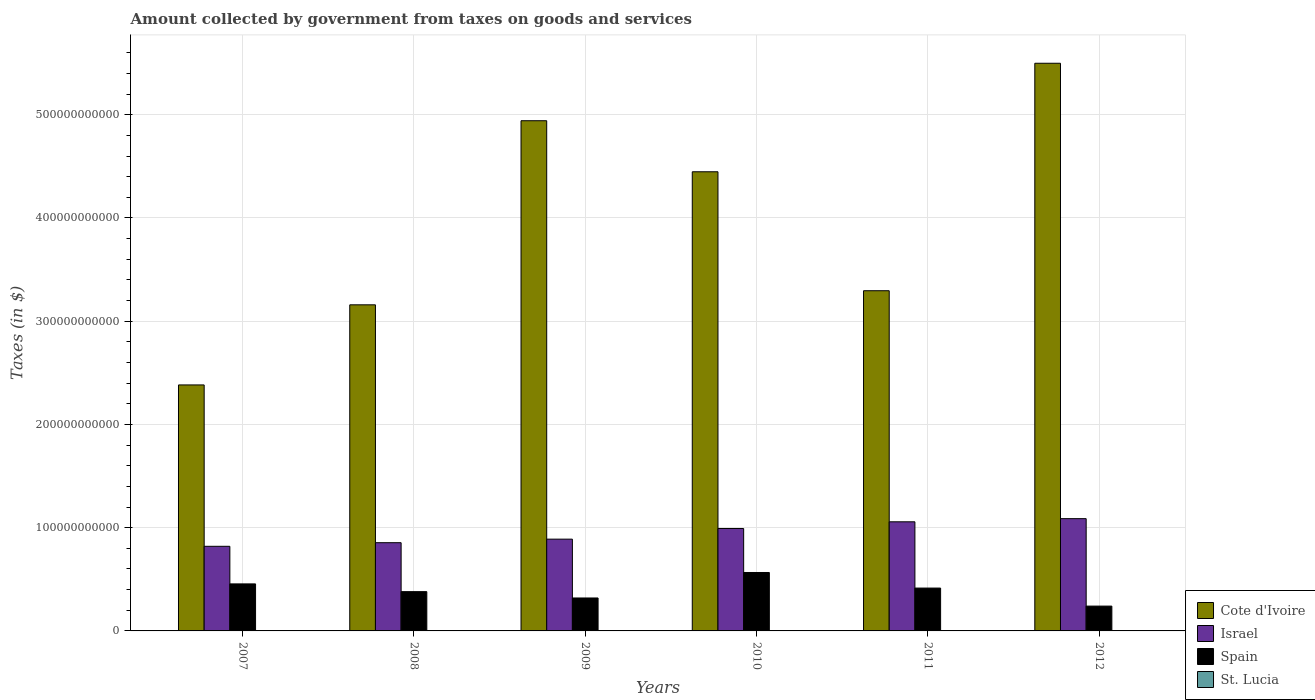How many different coloured bars are there?
Your response must be concise. 4. How many groups of bars are there?
Your answer should be compact. 6. Are the number of bars per tick equal to the number of legend labels?
Ensure brevity in your answer.  Yes. How many bars are there on the 4th tick from the left?
Provide a succinct answer. 4. In how many cases, is the number of bars for a given year not equal to the number of legend labels?
Give a very brief answer. 0. What is the amount collected by government from taxes on goods and services in Cote d'Ivoire in 2011?
Your response must be concise. 3.30e+11. Across all years, what is the maximum amount collected by government from taxes on goods and services in Israel?
Offer a terse response. 1.09e+11. Across all years, what is the minimum amount collected by government from taxes on goods and services in Cote d'Ivoire?
Provide a short and direct response. 2.38e+11. What is the total amount collected by government from taxes on goods and services in Israel in the graph?
Offer a terse response. 5.70e+11. What is the difference between the amount collected by government from taxes on goods and services in St. Lucia in 2007 and that in 2011?
Provide a succinct answer. -6.00e+06. What is the difference between the amount collected by government from taxes on goods and services in Spain in 2007 and the amount collected by government from taxes on goods and services in Cote d'Ivoire in 2011?
Offer a very short reply. -2.84e+11. What is the average amount collected by government from taxes on goods and services in Cote d'Ivoire per year?
Offer a very short reply. 3.95e+11. In the year 2011, what is the difference between the amount collected by government from taxes on goods and services in Israel and amount collected by government from taxes on goods and services in Spain?
Keep it short and to the point. 6.42e+1. What is the ratio of the amount collected by government from taxes on goods and services in Cote d'Ivoire in 2008 to that in 2010?
Make the answer very short. 0.71. Is the amount collected by government from taxes on goods and services in St. Lucia in 2007 less than that in 2010?
Your answer should be compact. Yes. Is the difference between the amount collected by government from taxes on goods and services in Israel in 2007 and 2008 greater than the difference between the amount collected by government from taxes on goods and services in Spain in 2007 and 2008?
Make the answer very short. No. What is the difference between the highest and the second highest amount collected by government from taxes on goods and services in Spain?
Your answer should be compact. 1.11e+1. What is the difference between the highest and the lowest amount collected by government from taxes on goods and services in Cote d'Ivoire?
Provide a succinct answer. 3.12e+11. Is it the case that in every year, the sum of the amount collected by government from taxes on goods and services in St. Lucia and amount collected by government from taxes on goods and services in Israel is greater than the sum of amount collected by government from taxes on goods and services in Spain and amount collected by government from taxes on goods and services in Cote d'Ivoire?
Provide a short and direct response. No. What does the 1st bar from the right in 2007 represents?
Provide a succinct answer. St. Lucia. Is it the case that in every year, the sum of the amount collected by government from taxes on goods and services in Spain and amount collected by government from taxes on goods and services in Cote d'Ivoire is greater than the amount collected by government from taxes on goods and services in St. Lucia?
Provide a succinct answer. Yes. How many bars are there?
Give a very brief answer. 24. What is the difference between two consecutive major ticks on the Y-axis?
Your answer should be compact. 1.00e+11. Are the values on the major ticks of Y-axis written in scientific E-notation?
Ensure brevity in your answer.  No. Does the graph contain grids?
Keep it short and to the point. Yes. What is the title of the graph?
Provide a short and direct response. Amount collected by government from taxes on goods and services. What is the label or title of the X-axis?
Offer a very short reply. Years. What is the label or title of the Y-axis?
Offer a terse response. Taxes (in $). What is the Taxes (in $) of Cote d'Ivoire in 2007?
Offer a very short reply. 2.38e+11. What is the Taxes (in $) in Israel in 2007?
Your response must be concise. 8.20e+1. What is the Taxes (in $) in Spain in 2007?
Make the answer very short. 4.55e+1. What is the Taxes (in $) in St. Lucia in 2007?
Ensure brevity in your answer.  1.20e+08. What is the Taxes (in $) of Cote d'Ivoire in 2008?
Make the answer very short. 3.16e+11. What is the Taxes (in $) of Israel in 2008?
Provide a short and direct response. 8.55e+1. What is the Taxes (in $) in Spain in 2008?
Make the answer very short. 3.80e+1. What is the Taxes (in $) of St. Lucia in 2008?
Your answer should be compact. 1.32e+08. What is the Taxes (in $) in Cote d'Ivoire in 2009?
Make the answer very short. 4.94e+11. What is the Taxes (in $) of Israel in 2009?
Give a very brief answer. 8.89e+1. What is the Taxes (in $) in Spain in 2009?
Provide a short and direct response. 3.19e+1. What is the Taxes (in $) in St. Lucia in 2009?
Provide a short and direct response. 1.07e+08. What is the Taxes (in $) of Cote d'Ivoire in 2010?
Provide a short and direct response. 4.45e+11. What is the Taxes (in $) of Israel in 2010?
Offer a terse response. 9.92e+1. What is the Taxes (in $) in Spain in 2010?
Provide a short and direct response. 5.66e+1. What is the Taxes (in $) in St. Lucia in 2010?
Keep it short and to the point. 1.25e+08. What is the Taxes (in $) of Cote d'Ivoire in 2011?
Provide a short and direct response. 3.30e+11. What is the Taxes (in $) of Israel in 2011?
Provide a succinct answer. 1.06e+11. What is the Taxes (in $) of Spain in 2011?
Provide a succinct answer. 4.15e+1. What is the Taxes (in $) of St. Lucia in 2011?
Your answer should be compact. 1.26e+08. What is the Taxes (in $) of Cote d'Ivoire in 2012?
Make the answer very short. 5.50e+11. What is the Taxes (in $) of Israel in 2012?
Your answer should be very brief. 1.09e+11. What is the Taxes (in $) in Spain in 2012?
Offer a very short reply. 2.40e+1. What is the Taxes (in $) in St. Lucia in 2012?
Your answer should be very brief. 1.83e+08. Across all years, what is the maximum Taxes (in $) in Cote d'Ivoire?
Give a very brief answer. 5.50e+11. Across all years, what is the maximum Taxes (in $) of Israel?
Your response must be concise. 1.09e+11. Across all years, what is the maximum Taxes (in $) in Spain?
Offer a very short reply. 5.66e+1. Across all years, what is the maximum Taxes (in $) of St. Lucia?
Give a very brief answer. 1.83e+08. Across all years, what is the minimum Taxes (in $) in Cote d'Ivoire?
Provide a short and direct response. 2.38e+11. Across all years, what is the minimum Taxes (in $) of Israel?
Provide a succinct answer. 8.20e+1. Across all years, what is the minimum Taxes (in $) in Spain?
Offer a very short reply. 2.40e+1. Across all years, what is the minimum Taxes (in $) of St. Lucia?
Offer a very short reply. 1.07e+08. What is the total Taxes (in $) in Cote d'Ivoire in the graph?
Keep it short and to the point. 2.37e+12. What is the total Taxes (in $) of Israel in the graph?
Offer a terse response. 5.70e+11. What is the total Taxes (in $) of Spain in the graph?
Offer a very short reply. 2.38e+11. What is the total Taxes (in $) in St. Lucia in the graph?
Your answer should be very brief. 7.93e+08. What is the difference between the Taxes (in $) of Cote d'Ivoire in 2007 and that in 2008?
Make the answer very short. -7.76e+1. What is the difference between the Taxes (in $) in Israel in 2007 and that in 2008?
Make the answer very short. -3.50e+09. What is the difference between the Taxes (in $) of Spain in 2007 and that in 2008?
Offer a very short reply. 7.50e+09. What is the difference between the Taxes (in $) in St. Lucia in 2007 and that in 2008?
Keep it short and to the point. -1.25e+07. What is the difference between the Taxes (in $) in Cote d'Ivoire in 2007 and that in 2009?
Offer a very short reply. -2.56e+11. What is the difference between the Taxes (in $) of Israel in 2007 and that in 2009?
Your answer should be very brief. -6.93e+09. What is the difference between the Taxes (in $) of Spain in 2007 and that in 2009?
Offer a very short reply. 1.36e+1. What is the difference between the Taxes (in $) in St. Lucia in 2007 and that in 2009?
Your answer should be very brief. 1.23e+07. What is the difference between the Taxes (in $) in Cote d'Ivoire in 2007 and that in 2010?
Offer a terse response. -2.06e+11. What is the difference between the Taxes (in $) of Israel in 2007 and that in 2010?
Ensure brevity in your answer.  -1.72e+1. What is the difference between the Taxes (in $) of Spain in 2007 and that in 2010?
Your answer should be very brief. -1.11e+1. What is the difference between the Taxes (in $) in St. Lucia in 2007 and that in 2010?
Give a very brief answer. -5.40e+06. What is the difference between the Taxes (in $) in Cote d'Ivoire in 2007 and that in 2011?
Ensure brevity in your answer.  -9.12e+1. What is the difference between the Taxes (in $) of Israel in 2007 and that in 2011?
Your answer should be very brief. -2.37e+1. What is the difference between the Taxes (in $) in Spain in 2007 and that in 2011?
Provide a short and direct response. 4.04e+09. What is the difference between the Taxes (in $) in St. Lucia in 2007 and that in 2011?
Keep it short and to the point. -6.00e+06. What is the difference between the Taxes (in $) of Cote d'Ivoire in 2007 and that in 2012?
Offer a terse response. -3.12e+11. What is the difference between the Taxes (in $) of Israel in 2007 and that in 2012?
Your answer should be very brief. -2.68e+1. What is the difference between the Taxes (in $) of Spain in 2007 and that in 2012?
Your answer should be very brief. 2.15e+1. What is the difference between the Taxes (in $) in St. Lucia in 2007 and that in 2012?
Your answer should be very brief. -6.29e+07. What is the difference between the Taxes (in $) in Cote d'Ivoire in 2008 and that in 2009?
Your answer should be very brief. -1.78e+11. What is the difference between the Taxes (in $) in Israel in 2008 and that in 2009?
Offer a very short reply. -3.43e+09. What is the difference between the Taxes (in $) of Spain in 2008 and that in 2009?
Offer a terse response. 6.14e+09. What is the difference between the Taxes (in $) of St. Lucia in 2008 and that in 2009?
Offer a terse response. 2.48e+07. What is the difference between the Taxes (in $) of Cote d'Ivoire in 2008 and that in 2010?
Offer a terse response. -1.29e+11. What is the difference between the Taxes (in $) in Israel in 2008 and that in 2010?
Make the answer very short. -1.38e+1. What is the difference between the Taxes (in $) in Spain in 2008 and that in 2010?
Give a very brief answer. -1.86e+1. What is the difference between the Taxes (in $) of St. Lucia in 2008 and that in 2010?
Your answer should be compact. 7.10e+06. What is the difference between the Taxes (in $) of Cote d'Ivoire in 2008 and that in 2011?
Give a very brief answer. -1.36e+1. What is the difference between the Taxes (in $) of Israel in 2008 and that in 2011?
Make the answer very short. -2.02e+1. What is the difference between the Taxes (in $) in Spain in 2008 and that in 2011?
Your response must be concise. -3.46e+09. What is the difference between the Taxes (in $) of St. Lucia in 2008 and that in 2011?
Your answer should be compact. 6.50e+06. What is the difference between the Taxes (in $) in Cote d'Ivoire in 2008 and that in 2012?
Give a very brief answer. -2.34e+11. What is the difference between the Taxes (in $) of Israel in 2008 and that in 2012?
Your response must be concise. -2.33e+1. What is the difference between the Taxes (in $) of Spain in 2008 and that in 2012?
Provide a short and direct response. 1.40e+1. What is the difference between the Taxes (in $) of St. Lucia in 2008 and that in 2012?
Provide a succinct answer. -5.04e+07. What is the difference between the Taxes (in $) in Cote d'Ivoire in 2009 and that in 2010?
Provide a succinct answer. 4.94e+1. What is the difference between the Taxes (in $) of Israel in 2009 and that in 2010?
Give a very brief answer. -1.03e+1. What is the difference between the Taxes (in $) in Spain in 2009 and that in 2010?
Provide a succinct answer. -2.47e+1. What is the difference between the Taxes (in $) of St. Lucia in 2009 and that in 2010?
Provide a short and direct response. -1.77e+07. What is the difference between the Taxes (in $) in Cote d'Ivoire in 2009 and that in 2011?
Offer a very short reply. 1.65e+11. What is the difference between the Taxes (in $) in Israel in 2009 and that in 2011?
Give a very brief answer. -1.68e+1. What is the difference between the Taxes (in $) of Spain in 2009 and that in 2011?
Give a very brief answer. -9.60e+09. What is the difference between the Taxes (in $) of St. Lucia in 2009 and that in 2011?
Your answer should be compact. -1.83e+07. What is the difference between the Taxes (in $) of Cote d'Ivoire in 2009 and that in 2012?
Your answer should be compact. -5.57e+1. What is the difference between the Taxes (in $) of Israel in 2009 and that in 2012?
Provide a succinct answer. -1.99e+1. What is the difference between the Taxes (in $) in Spain in 2009 and that in 2012?
Offer a very short reply. 7.87e+09. What is the difference between the Taxes (in $) of St. Lucia in 2009 and that in 2012?
Your response must be concise. -7.52e+07. What is the difference between the Taxes (in $) in Cote d'Ivoire in 2010 and that in 2011?
Make the answer very short. 1.15e+11. What is the difference between the Taxes (in $) of Israel in 2010 and that in 2011?
Your response must be concise. -6.48e+09. What is the difference between the Taxes (in $) of Spain in 2010 and that in 2011?
Offer a very short reply. 1.51e+1. What is the difference between the Taxes (in $) in St. Lucia in 2010 and that in 2011?
Make the answer very short. -6.00e+05. What is the difference between the Taxes (in $) in Cote d'Ivoire in 2010 and that in 2012?
Your answer should be compact. -1.05e+11. What is the difference between the Taxes (in $) in Israel in 2010 and that in 2012?
Offer a very short reply. -9.53e+09. What is the difference between the Taxes (in $) in Spain in 2010 and that in 2012?
Provide a succinct answer. 3.26e+1. What is the difference between the Taxes (in $) of St. Lucia in 2010 and that in 2012?
Offer a terse response. -5.75e+07. What is the difference between the Taxes (in $) in Cote d'Ivoire in 2011 and that in 2012?
Provide a short and direct response. -2.20e+11. What is the difference between the Taxes (in $) in Israel in 2011 and that in 2012?
Ensure brevity in your answer.  -3.06e+09. What is the difference between the Taxes (in $) of Spain in 2011 and that in 2012?
Provide a short and direct response. 1.75e+1. What is the difference between the Taxes (in $) of St. Lucia in 2011 and that in 2012?
Your answer should be compact. -5.69e+07. What is the difference between the Taxes (in $) of Cote d'Ivoire in 2007 and the Taxes (in $) of Israel in 2008?
Provide a short and direct response. 1.53e+11. What is the difference between the Taxes (in $) of Cote d'Ivoire in 2007 and the Taxes (in $) of Spain in 2008?
Ensure brevity in your answer.  2.00e+11. What is the difference between the Taxes (in $) of Cote d'Ivoire in 2007 and the Taxes (in $) of St. Lucia in 2008?
Keep it short and to the point. 2.38e+11. What is the difference between the Taxes (in $) of Israel in 2007 and the Taxes (in $) of Spain in 2008?
Offer a terse response. 4.39e+1. What is the difference between the Taxes (in $) in Israel in 2007 and the Taxes (in $) in St. Lucia in 2008?
Keep it short and to the point. 8.18e+1. What is the difference between the Taxes (in $) of Spain in 2007 and the Taxes (in $) of St. Lucia in 2008?
Your answer should be very brief. 4.54e+1. What is the difference between the Taxes (in $) of Cote d'Ivoire in 2007 and the Taxes (in $) of Israel in 2009?
Keep it short and to the point. 1.49e+11. What is the difference between the Taxes (in $) in Cote d'Ivoire in 2007 and the Taxes (in $) in Spain in 2009?
Offer a very short reply. 2.06e+11. What is the difference between the Taxes (in $) of Cote d'Ivoire in 2007 and the Taxes (in $) of St. Lucia in 2009?
Offer a very short reply. 2.38e+11. What is the difference between the Taxes (in $) in Israel in 2007 and the Taxes (in $) in Spain in 2009?
Keep it short and to the point. 5.01e+1. What is the difference between the Taxes (in $) of Israel in 2007 and the Taxes (in $) of St. Lucia in 2009?
Give a very brief answer. 8.19e+1. What is the difference between the Taxes (in $) of Spain in 2007 and the Taxes (in $) of St. Lucia in 2009?
Offer a very short reply. 4.54e+1. What is the difference between the Taxes (in $) in Cote d'Ivoire in 2007 and the Taxes (in $) in Israel in 2010?
Your response must be concise. 1.39e+11. What is the difference between the Taxes (in $) in Cote d'Ivoire in 2007 and the Taxes (in $) in Spain in 2010?
Your answer should be compact. 1.82e+11. What is the difference between the Taxes (in $) of Cote d'Ivoire in 2007 and the Taxes (in $) of St. Lucia in 2010?
Ensure brevity in your answer.  2.38e+11. What is the difference between the Taxes (in $) in Israel in 2007 and the Taxes (in $) in Spain in 2010?
Give a very brief answer. 2.54e+1. What is the difference between the Taxes (in $) in Israel in 2007 and the Taxes (in $) in St. Lucia in 2010?
Make the answer very short. 8.18e+1. What is the difference between the Taxes (in $) of Spain in 2007 and the Taxes (in $) of St. Lucia in 2010?
Keep it short and to the point. 4.54e+1. What is the difference between the Taxes (in $) of Cote d'Ivoire in 2007 and the Taxes (in $) of Israel in 2011?
Your answer should be very brief. 1.33e+11. What is the difference between the Taxes (in $) of Cote d'Ivoire in 2007 and the Taxes (in $) of Spain in 2011?
Make the answer very short. 1.97e+11. What is the difference between the Taxes (in $) of Cote d'Ivoire in 2007 and the Taxes (in $) of St. Lucia in 2011?
Give a very brief answer. 2.38e+11. What is the difference between the Taxes (in $) in Israel in 2007 and the Taxes (in $) in Spain in 2011?
Ensure brevity in your answer.  4.05e+1. What is the difference between the Taxes (in $) of Israel in 2007 and the Taxes (in $) of St. Lucia in 2011?
Provide a short and direct response. 8.18e+1. What is the difference between the Taxes (in $) of Spain in 2007 and the Taxes (in $) of St. Lucia in 2011?
Keep it short and to the point. 4.54e+1. What is the difference between the Taxes (in $) in Cote d'Ivoire in 2007 and the Taxes (in $) in Israel in 2012?
Offer a terse response. 1.30e+11. What is the difference between the Taxes (in $) of Cote d'Ivoire in 2007 and the Taxes (in $) of Spain in 2012?
Offer a terse response. 2.14e+11. What is the difference between the Taxes (in $) in Cote d'Ivoire in 2007 and the Taxes (in $) in St. Lucia in 2012?
Your response must be concise. 2.38e+11. What is the difference between the Taxes (in $) in Israel in 2007 and the Taxes (in $) in Spain in 2012?
Provide a succinct answer. 5.79e+1. What is the difference between the Taxes (in $) of Israel in 2007 and the Taxes (in $) of St. Lucia in 2012?
Provide a short and direct response. 8.18e+1. What is the difference between the Taxes (in $) in Spain in 2007 and the Taxes (in $) in St. Lucia in 2012?
Your answer should be very brief. 4.54e+1. What is the difference between the Taxes (in $) of Cote d'Ivoire in 2008 and the Taxes (in $) of Israel in 2009?
Give a very brief answer. 2.27e+11. What is the difference between the Taxes (in $) of Cote d'Ivoire in 2008 and the Taxes (in $) of Spain in 2009?
Offer a terse response. 2.84e+11. What is the difference between the Taxes (in $) of Cote d'Ivoire in 2008 and the Taxes (in $) of St. Lucia in 2009?
Provide a succinct answer. 3.16e+11. What is the difference between the Taxes (in $) of Israel in 2008 and the Taxes (in $) of Spain in 2009?
Your answer should be very brief. 5.36e+1. What is the difference between the Taxes (in $) of Israel in 2008 and the Taxes (in $) of St. Lucia in 2009?
Keep it short and to the point. 8.54e+1. What is the difference between the Taxes (in $) in Spain in 2008 and the Taxes (in $) in St. Lucia in 2009?
Your answer should be very brief. 3.79e+1. What is the difference between the Taxes (in $) in Cote d'Ivoire in 2008 and the Taxes (in $) in Israel in 2010?
Offer a very short reply. 2.17e+11. What is the difference between the Taxes (in $) in Cote d'Ivoire in 2008 and the Taxes (in $) in Spain in 2010?
Provide a short and direct response. 2.59e+11. What is the difference between the Taxes (in $) in Cote d'Ivoire in 2008 and the Taxes (in $) in St. Lucia in 2010?
Your answer should be very brief. 3.16e+11. What is the difference between the Taxes (in $) of Israel in 2008 and the Taxes (in $) of Spain in 2010?
Keep it short and to the point. 2.89e+1. What is the difference between the Taxes (in $) of Israel in 2008 and the Taxes (in $) of St. Lucia in 2010?
Keep it short and to the point. 8.53e+1. What is the difference between the Taxes (in $) in Spain in 2008 and the Taxes (in $) in St. Lucia in 2010?
Keep it short and to the point. 3.79e+1. What is the difference between the Taxes (in $) in Cote d'Ivoire in 2008 and the Taxes (in $) in Israel in 2011?
Give a very brief answer. 2.10e+11. What is the difference between the Taxes (in $) in Cote d'Ivoire in 2008 and the Taxes (in $) in Spain in 2011?
Your answer should be compact. 2.74e+11. What is the difference between the Taxes (in $) in Cote d'Ivoire in 2008 and the Taxes (in $) in St. Lucia in 2011?
Keep it short and to the point. 3.16e+11. What is the difference between the Taxes (in $) in Israel in 2008 and the Taxes (in $) in Spain in 2011?
Your response must be concise. 4.40e+1. What is the difference between the Taxes (in $) in Israel in 2008 and the Taxes (in $) in St. Lucia in 2011?
Your answer should be very brief. 8.53e+1. What is the difference between the Taxes (in $) in Spain in 2008 and the Taxes (in $) in St. Lucia in 2011?
Provide a short and direct response. 3.79e+1. What is the difference between the Taxes (in $) of Cote d'Ivoire in 2008 and the Taxes (in $) of Israel in 2012?
Provide a succinct answer. 2.07e+11. What is the difference between the Taxes (in $) in Cote d'Ivoire in 2008 and the Taxes (in $) in Spain in 2012?
Keep it short and to the point. 2.92e+11. What is the difference between the Taxes (in $) in Cote d'Ivoire in 2008 and the Taxes (in $) in St. Lucia in 2012?
Your answer should be compact. 3.16e+11. What is the difference between the Taxes (in $) in Israel in 2008 and the Taxes (in $) in Spain in 2012?
Your response must be concise. 6.14e+1. What is the difference between the Taxes (in $) of Israel in 2008 and the Taxes (in $) of St. Lucia in 2012?
Offer a very short reply. 8.53e+1. What is the difference between the Taxes (in $) of Spain in 2008 and the Taxes (in $) of St. Lucia in 2012?
Your answer should be compact. 3.79e+1. What is the difference between the Taxes (in $) of Cote d'Ivoire in 2009 and the Taxes (in $) of Israel in 2010?
Make the answer very short. 3.95e+11. What is the difference between the Taxes (in $) in Cote d'Ivoire in 2009 and the Taxes (in $) in Spain in 2010?
Make the answer very short. 4.38e+11. What is the difference between the Taxes (in $) of Cote d'Ivoire in 2009 and the Taxes (in $) of St. Lucia in 2010?
Offer a terse response. 4.94e+11. What is the difference between the Taxes (in $) of Israel in 2009 and the Taxes (in $) of Spain in 2010?
Your answer should be very brief. 3.23e+1. What is the difference between the Taxes (in $) of Israel in 2009 and the Taxes (in $) of St. Lucia in 2010?
Offer a terse response. 8.88e+1. What is the difference between the Taxes (in $) of Spain in 2009 and the Taxes (in $) of St. Lucia in 2010?
Keep it short and to the point. 3.18e+1. What is the difference between the Taxes (in $) in Cote d'Ivoire in 2009 and the Taxes (in $) in Israel in 2011?
Your answer should be very brief. 3.89e+11. What is the difference between the Taxes (in $) in Cote d'Ivoire in 2009 and the Taxes (in $) in Spain in 2011?
Your response must be concise. 4.53e+11. What is the difference between the Taxes (in $) in Cote d'Ivoire in 2009 and the Taxes (in $) in St. Lucia in 2011?
Your answer should be very brief. 4.94e+11. What is the difference between the Taxes (in $) in Israel in 2009 and the Taxes (in $) in Spain in 2011?
Keep it short and to the point. 4.74e+1. What is the difference between the Taxes (in $) in Israel in 2009 and the Taxes (in $) in St. Lucia in 2011?
Offer a terse response. 8.88e+1. What is the difference between the Taxes (in $) of Spain in 2009 and the Taxes (in $) of St. Lucia in 2011?
Offer a terse response. 3.18e+1. What is the difference between the Taxes (in $) in Cote d'Ivoire in 2009 and the Taxes (in $) in Israel in 2012?
Your response must be concise. 3.85e+11. What is the difference between the Taxes (in $) in Cote d'Ivoire in 2009 and the Taxes (in $) in Spain in 2012?
Provide a succinct answer. 4.70e+11. What is the difference between the Taxes (in $) in Cote d'Ivoire in 2009 and the Taxes (in $) in St. Lucia in 2012?
Offer a very short reply. 4.94e+11. What is the difference between the Taxes (in $) of Israel in 2009 and the Taxes (in $) of Spain in 2012?
Your answer should be very brief. 6.49e+1. What is the difference between the Taxes (in $) in Israel in 2009 and the Taxes (in $) in St. Lucia in 2012?
Give a very brief answer. 8.87e+1. What is the difference between the Taxes (in $) in Spain in 2009 and the Taxes (in $) in St. Lucia in 2012?
Ensure brevity in your answer.  3.17e+1. What is the difference between the Taxes (in $) in Cote d'Ivoire in 2010 and the Taxes (in $) in Israel in 2011?
Keep it short and to the point. 3.39e+11. What is the difference between the Taxes (in $) of Cote d'Ivoire in 2010 and the Taxes (in $) of Spain in 2011?
Provide a succinct answer. 4.03e+11. What is the difference between the Taxes (in $) in Cote d'Ivoire in 2010 and the Taxes (in $) in St. Lucia in 2011?
Your answer should be compact. 4.45e+11. What is the difference between the Taxes (in $) in Israel in 2010 and the Taxes (in $) in Spain in 2011?
Make the answer very short. 5.77e+1. What is the difference between the Taxes (in $) in Israel in 2010 and the Taxes (in $) in St. Lucia in 2011?
Make the answer very short. 9.91e+1. What is the difference between the Taxes (in $) of Spain in 2010 and the Taxes (in $) of St. Lucia in 2011?
Your response must be concise. 5.65e+1. What is the difference between the Taxes (in $) of Cote d'Ivoire in 2010 and the Taxes (in $) of Israel in 2012?
Make the answer very short. 3.36e+11. What is the difference between the Taxes (in $) of Cote d'Ivoire in 2010 and the Taxes (in $) of Spain in 2012?
Make the answer very short. 4.21e+11. What is the difference between the Taxes (in $) of Cote d'Ivoire in 2010 and the Taxes (in $) of St. Lucia in 2012?
Your answer should be compact. 4.45e+11. What is the difference between the Taxes (in $) of Israel in 2010 and the Taxes (in $) of Spain in 2012?
Your answer should be very brief. 7.52e+1. What is the difference between the Taxes (in $) of Israel in 2010 and the Taxes (in $) of St. Lucia in 2012?
Your answer should be very brief. 9.90e+1. What is the difference between the Taxes (in $) in Spain in 2010 and the Taxes (in $) in St. Lucia in 2012?
Your answer should be very brief. 5.64e+1. What is the difference between the Taxes (in $) in Cote d'Ivoire in 2011 and the Taxes (in $) in Israel in 2012?
Make the answer very short. 2.21e+11. What is the difference between the Taxes (in $) of Cote d'Ivoire in 2011 and the Taxes (in $) of Spain in 2012?
Ensure brevity in your answer.  3.06e+11. What is the difference between the Taxes (in $) of Cote d'Ivoire in 2011 and the Taxes (in $) of St. Lucia in 2012?
Make the answer very short. 3.29e+11. What is the difference between the Taxes (in $) of Israel in 2011 and the Taxes (in $) of Spain in 2012?
Your answer should be very brief. 8.17e+1. What is the difference between the Taxes (in $) in Israel in 2011 and the Taxes (in $) in St. Lucia in 2012?
Your response must be concise. 1.06e+11. What is the difference between the Taxes (in $) in Spain in 2011 and the Taxes (in $) in St. Lucia in 2012?
Provide a succinct answer. 4.13e+1. What is the average Taxes (in $) in Cote d'Ivoire per year?
Keep it short and to the point. 3.95e+11. What is the average Taxes (in $) in Israel per year?
Your answer should be compact. 9.50e+1. What is the average Taxes (in $) in Spain per year?
Provide a succinct answer. 3.96e+1. What is the average Taxes (in $) of St. Lucia per year?
Offer a very short reply. 1.32e+08. In the year 2007, what is the difference between the Taxes (in $) in Cote d'Ivoire and Taxes (in $) in Israel?
Ensure brevity in your answer.  1.56e+11. In the year 2007, what is the difference between the Taxes (in $) of Cote d'Ivoire and Taxes (in $) of Spain?
Your answer should be very brief. 1.93e+11. In the year 2007, what is the difference between the Taxes (in $) in Cote d'Ivoire and Taxes (in $) in St. Lucia?
Offer a terse response. 2.38e+11. In the year 2007, what is the difference between the Taxes (in $) of Israel and Taxes (in $) of Spain?
Give a very brief answer. 3.64e+1. In the year 2007, what is the difference between the Taxes (in $) in Israel and Taxes (in $) in St. Lucia?
Keep it short and to the point. 8.19e+1. In the year 2007, what is the difference between the Taxes (in $) in Spain and Taxes (in $) in St. Lucia?
Your answer should be compact. 4.54e+1. In the year 2008, what is the difference between the Taxes (in $) of Cote d'Ivoire and Taxes (in $) of Israel?
Your response must be concise. 2.30e+11. In the year 2008, what is the difference between the Taxes (in $) in Cote d'Ivoire and Taxes (in $) in Spain?
Make the answer very short. 2.78e+11. In the year 2008, what is the difference between the Taxes (in $) of Cote d'Ivoire and Taxes (in $) of St. Lucia?
Offer a very short reply. 3.16e+11. In the year 2008, what is the difference between the Taxes (in $) in Israel and Taxes (in $) in Spain?
Provide a short and direct response. 4.74e+1. In the year 2008, what is the difference between the Taxes (in $) in Israel and Taxes (in $) in St. Lucia?
Give a very brief answer. 8.53e+1. In the year 2008, what is the difference between the Taxes (in $) in Spain and Taxes (in $) in St. Lucia?
Ensure brevity in your answer.  3.79e+1. In the year 2009, what is the difference between the Taxes (in $) of Cote d'Ivoire and Taxes (in $) of Israel?
Provide a short and direct response. 4.05e+11. In the year 2009, what is the difference between the Taxes (in $) in Cote d'Ivoire and Taxes (in $) in Spain?
Offer a very short reply. 4.62e+11. In the year 2009, what is the difference between the Taxes (in $) in Cote d'Ivoire and Taxes (in $) in St. Lucia?
Your answer should be compact. 4.94e+11. In the year 2009, what is the difference between the Taxes (in $) in Israel and Taxes (in $) in Spain?
Offer a terse response. 5.70e+1. In the year 2009, what is the difference between the Taxes (in $) in Israel and Taxes (in $) in St. Lucia?
Provide a succinct answer. 8.88e+1. In the year 2009, what is the difference between the Taxes (in $) in Spain and Taxes (in $) in St. Lucia?
Offer a very short reply. 3.18e+1. In the year 2010, what is the difference between the Taxes (in $) in Cote d'Ivoire and Taxes (in $) in Israel?
Give a very brief answer. 3.46e+11. In the year 2010, what is the difference between the Taxes (in $) of Cote d'Ivoire and Taxes (in $) of Spain?
Give a very brief answer. 3.88e+11. In the year 2010, what is the difference between the Taxes (in $) in Cote d'Ivoire and Taxes (in $) in St. Lucia?
Your answer should be compact. 4.45e+11. In the year 2010, what is the difference between the Taxes (in $) of Israel and Taxes (in $) of Spain?
Your answer should be very brief. 4.26e+1. In the year 2010, what is the difference between the Taxes (in $) in Israel and Taxes (in $) in St. Lucia?
Your answer should be compact. 9.91e+1. In the year 2010, what is the difference between the Taxes (in $) in Spain and Taxes (in $) in St. Lucia?
Provide a succinct answer. 5.65e+1. In the year 2011, what is the difference between the Taxes (in $) in Cote d'Ivoire and Taxes (in $) in Israel?
Provide a succinct answer. 2.24e+11. In the year 2011, what is the difference between the Taxes (in $) of Cote d'Ivoire and Taxes (in $) of Spain?
Ensure brevity in your answer.  2.88e+11. In the year 2011, what is the difference between the Taxes (in $) of Cote d'Ivoire and Taxes (in $) of St. Lucia?
Provide a short and direct response. 3.29e+11. In the year 2011, what is the difference between the Taxes (in $) in Israel and Taxes (in $) in Spain?
Keep it short and to the point. 6.42e+1. In the year 2011, what is the difference between the Taxes (in $) in Israel and Taxes (in $) in St. Lucia?
Ensure brevity in your answer.  1.06e+11. In the year 2011, what is the difference between the Taxes (in $) of Spain and Taxes (in $) of St. Lucia?
Offer a terse response. 4.14e+1. In the year 2012, what is the difference between the Taxes (in $) in Cote d'Ivoire and Taxes (in $) in Israel?
Your answer should be very brief. 4.41e+11. In the year 2012, what is the difference between the Taxes (in $) in Cote d'Ivoire and Taxes (in $) in Spain?
Offer a very short reply. 5.26e+11. In the year 2012, what is the difference between the Taxes (in $) in Cote d'Ivoire and Taxes (in $) in St. Lucia?
Give a very brief answer. 5.50e+11. In the year 2012, what is the difference between the Taxes (in $) of Israel and Taxes (in $) of Spain?
Make the answer very short. 8.47e+1. In the year 2012, what is the difference between the Taxes (in $) of Israel and Taxes (in $) of St. Lucia?
Offer a very short reply. 1.09e+11. In the year 2012, what is the difference between the Taxes (in $) of Spain and Taxes (in $) of St. Lucia?
Provide a short and direct response. 2.39e+1. What is the ratio of the Taxes (in $) in Cote d'Ivoire in 2007 to that in 2008?
Keep it short and to the point. 0.75. What is the ratio of the Taxes (in $) of Israel in 2007 to that in 2008?
Provide a succinct answer. 0.96. What is the ratio of the Taxes (in $) of Spain in 2007 to that in 2008?
Your response must be concise. 1.2. What is the ratio of the Taxes (in $) of St. Lucia in 2007 to that in 2008?
Make the answer very short. 0.91. What is the ratio of the Taxes (in $) of Cote d'Ivoire in 2007 to that in 2009?
Provide a short and direct response. 0.48. What is the ratio of the Taxes (in $) in Israel in 2007 to that in 2009?
Your answer should be compact. 0.92. What is the ratio of the Taxes (in $) in Spain in 2007 to that in 2009?
Ensure brevity in your answer.  1.43. What is the ratio of the Taxes (in $) in St. Lucia in 2007 to that in 2009?
Keep it short and to the point. 1.11. What is the ratio of the Taxes (in $) of Cote d'Ivoire in 2007 to that in 2010?
Keep it short and to the point. 0.54. What is the ratio of the Taxes (in $) of Israel in 2007 to that in 2010?
Your response must be concise. 0.83. What is the ratio of the Taxes (in $) of Spain in 2007 to that in 2010?
Offer a very short reply. 0.8. What is the ratio of the Taxes (in $) in St. Lucia in 2007 to that in 2010?
Ensure brevity in your answer.  0.96. What is the ratio of the Taxes (in $) in Cote d'Ivoire in 2007 to that in 2011?
Keep it short and to the point. 0.72. What is the ratio of the Taxes (in $) of Israel in 2007 to that in 2011?
Your response must be concise. 0.78. What is the ratio of the Taxes (in $) in Spain in 2007 to that in 2011?
Give a very brief answer. 1.1. What is the ratio of the Taxes (in $) of St. Lucia in 2007 to that in 2011?
Offer a very short reply. 0.95. What is the ratio of the Taxes (in $) in Cote d'Ivoire in 2007 to that in 2012?
Your response must be concise. 0.43. What is the ratio of the Taxes (in $) in Israel in 2007 to that in 2012?
Offer a very short reply. 0.75. What is the ratio of the Taxes (in $) of Spain in 2007 to that in 2012?
Keep it short and to the point. 1.9. What is the ratio of the Taxes (in $) of St. Lucia in 2007 to that in 2012?
Make the answer very short. 0.66. What is the ratio of the Taxes (in $) of Cote d'Ivoire in 2008 to that in 2009?
Ensure brevity in your answer.  0.64. What is the ratio of the Taxes (in $) of Israel in 2008 to that in 2009?
Make the answer very short. 0.96. What is the ratio of the Taxes (in $) of Spain in 2008 to that in 2009?
Provide a succinct answer. 1.19. What is the ratio of the Taxes (in $) of St. Lucia in 2008 to that in 2009?
Your response must be concise. 1.23. What is the ratio of the Taxes (in $) in Cote d'Ivoire in 2008 to that in 2010?
Give a very brief answer. 0.71. What is the ratio of the Taxes (in $) in Israel in 2008 to that in 2010?
Give a very brief answer. 0.86. What is the ratio of the Taxes (in $) of Spain in 2008 to that in 2010?
Offer a very short reply. 0.67. What is the ratio of the Taxes (in $) in St. Lucia in 2008 to that in 2010?
Offer a very short reply. 1.06. What is the ratio of the Taxes (in $) in Cote d'Ivoire in 2008 to that in 2011?
Offer a terse response. 0.96. What is the ratio of the Taxes (in $) of Israel in 2008 to that in 2011?
Give a very brief answer. 0.81. What is the ratio of the Taxes (in $) of Spain in 2008 to that in 2011?
Your answer should be very brief. 0.92. What is the ratio of the Taxes (in $) of St. Lucia in 2008 to that in 2011?
Your answer should be compact. 1.05. What is the ratio of the Taxes (in $) of Cote d'Ivoire in 2008 to that in 2012?
Your answer should be compact. 0.57. What is the ratio of the Taxes (in $) of Israel in 2008 to that in 2012?
Provide a succinct answer. 0.79. What is the ratio of the Taxes (in $) of Spain in 2008 to that in 2012?
Ensure brevity in your answer.  1.58. What is the ratio of the Taxes (in $) in St. Lucia in 2008 to that in 2012?
Ensure brevity in your answer.  0.72. What is the ratio of the Taxes (in $) of Cote d'Ivoire in 2009 to that in 2010?
Provide a short and direct response. 1.11. What is the ratio of the Taxes (in $) in Israel in 2009 to that in 2010?
Offer a very short reply. 0.9. What is the ratio of the Taxes (in $) of Spain in 2009 to that in 2010?
Give a very brief answer. 0.56. What is the ratio of the Taxes (in $) in St. Lucia in 2009 to that in 2010?
Offer a very short reply. 0.86. What is the ratio of the Taxes (in $) of Cote d'Ivoire in 2009 to that in 2011?
Provide a short and direct response. 1.5. What is the ratio of the Taxes (in $) in Israel in 2009 to that in 2011?
Offer a terse response. 0.84. What is the ratio of the Taxes (in $) of Spain in 2009 to that in 2011?
Give a very brief answer. 0.77. What is the ratio of the Taxes (in $) of St. Lucia in 2009 to that in 2011?
Provide a short and direct response. 0.85. What is the ratio of the Taxes (in $) in Cote d'Ivoire in 2009 to that in 2012?
Your answer should be compact. 0.9. What is the ratio of the Taxes (in $) of Israel in 2009 to that in 2012?
Offer a very short reply. 0.82. What is the ratio of the Taxes (in $) of Spain in 2009 to that in 2012?
Ensure brevity in your answer.  1.33. What is the ratio of the Taxes (in $) of St. Lucia in 2009 to that in 2012?
Your answer should be compact. 0.59. What is the ratio of the Taxes (in $) of Cote d'Ivoire in 2010 to that in 2011?
Keep it short and to the point. 1.35. What is the ratio of the Taxes (in $) of Israel in 2010 to that in 2011?
Keep it short and to the point. 0.94. What is the ratio of the Taxes (in $) of Spain in 2010 to that in 2011?
Give a very brief answer. 1.36. What is the ratio of the Taxes (in $) in St. Lucia in 2010 to that in 2011?
Ensure brevity in your answer.  1. What is the ratio of the Taxes (in $) in Cote d'Ivoire in 2010 to that in 2012?
Ensure brevity in your answer.  0.81. What is the ratio of the Taxes (in $) in Israel in 2010 to that in 2012?
Your response must be concise. 0.91. What is the ratio of the Taxes (in $) in Spain in 2010 to that in 2012?
Offer a terse response. 2.35. What is the ratio of the Taxes (in $) in St. Lucia in 2010 to that in 2012?
Make the answer very short. 0.69. What is the ratio of the Taxes (in $) of Cote d'Ivoire in 2011 to that in 2012?
Ensure brevity in your answer.  0.6. What is the ratio of the Taxes (in $) in Israel in 2011 to that in 2012?
Keep it short and to the point. 0.97. What is the ratio of the Taxes (in $) in Spain in 2011 to that in 2012?
Your response must be concise. 1.73. What is the ratio of the Taxes (in $) of St. Lucia in 2011 to that in 2012?
Keep it short and to the point. 0.69. What is the difference between the highest and the second highest Taxes (in $) of Cote d'Ivoire?
Your answer should be compact. 5.57e+1. What is the difference between the highest and the second highest Taxes (in $) of Israel?
Provide a succinct answer. 3.06e+09. What is the difference between the highest and the second highest Taxes (in $) in Spain?
Ensure brevity in your answer.  1.11e+1. What is the difference between the highest and the second highest Taxes (in $) of St. Lucia?
Offer a terse response. 5.04e+07. What is the difference between the highest and the lowest Taxes (in $) in Cote d'Ivoire?
Give a very brief answer. 3.12e+11. What is the difference between the highest and the lowest Taxes (in $) of Israel?
Ensure brevity in your answer.  2.68e+1. What is the difference between the highest and the lowest Taxes (in $) of Spain?
Give a very brief answer. 3.26e+1. What is the difference between the highest and the lowest Taxes (in $) of St. Lucia?
Make the answer very short. 7.52e+07. 